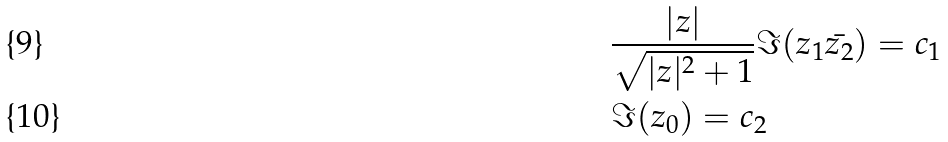<formula> <loc_0><loc_0><loc_500><loc_500>& \frac { | z | } { \sqrt { | z | ^ { 2 } + 1 } } \Im ( z _ { 1 } \bar { z _ { 2 } } ) = c _ { 1 } \\ & \Im ( z _ { 0 } ) = c _ { 2 }</formula> 